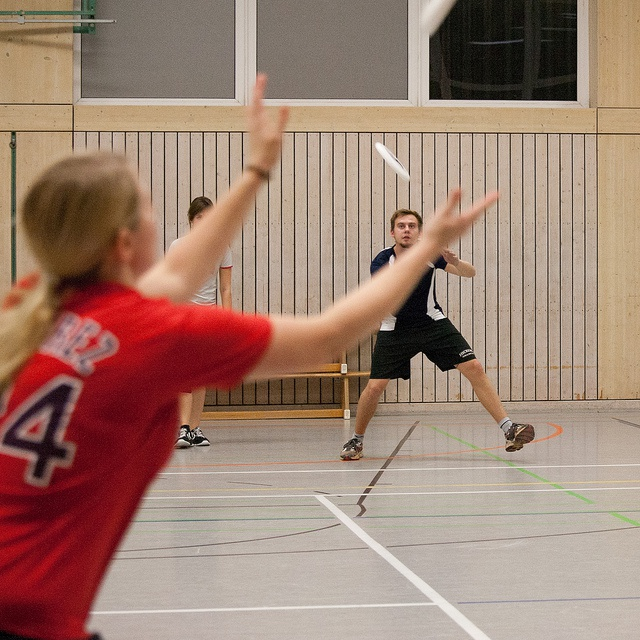Describe the objects in this image and their specific colors. I can see people in gray, maroon, brown, and tan tones, people in gray, black, maroon, and tan tones, people in gray, darkgray, tan, and black tones, bench in gray, olive, maroon, and tan tones, and frisbee in gray, lightgray, tan, and darkgray tones in this image. 